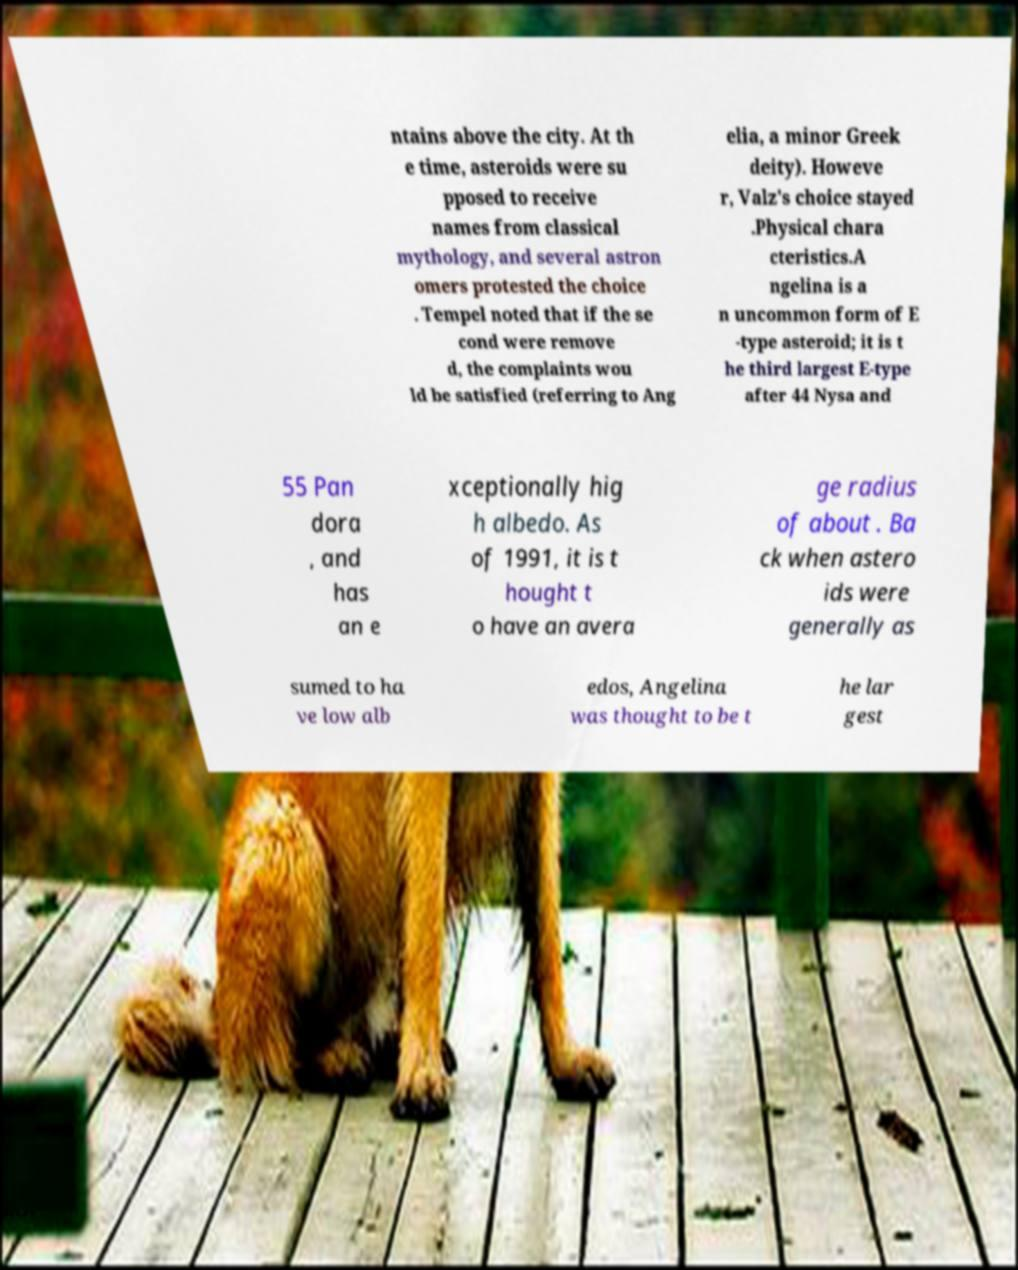Please identify and transcribe the text found in this image. ntains above the city. At th e time, asteroids were su pposed to receive names from classical mythology, and several astron omers protested the choice . Tempel noted that if the se cond were remove d, the complaints wou ld be satisfied (referring to Ang elia, a minor Greek deity). Howeve r, Valz's choice stayed .Physical chara cteristics.A ngelina is a n uncommon form of E -type asteroid; it is t he third largest E-type after 44 Nysa and 55 Pan dora , and has an e xceptionally hig h albedo. As of 1991, it is t hought t o have an avera ge radius of about . Ba ck when astero ids were generally as sumed to ha ve low alb edos, Angelina was thought to be t he lar gest 